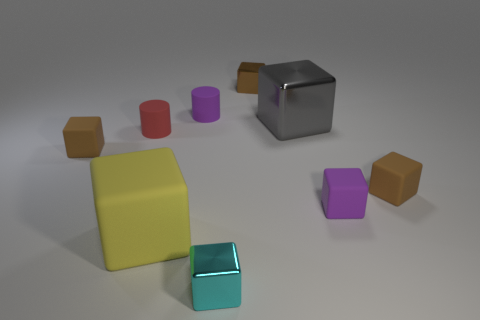Do the red thing and the brown metal thing have the same size?
Ensure brevity in your answer.  Yes. Are there any big yellow cubes that have the same material as the small purple cylinder?
Keep it short and to the point. Yes. What number of small blocks are both on the right side of the cyan thing and on the left side of the gray object?
Give a very brief answer. 1. What is the material of the large block that is behind the large matte thing?
Offer a very short reply. Metal. How many small rubber cylinders are the same color as the large rubber object?
Your answer should be compact. 0. The purple cylinder that is the same material as the red cylinder is what size?
Provide a short and direct response. Small. What number of things are small cylinders or large brown metal cylinders?
Give a very brief answer. 2. What color is the rubber cylinder that is to the right of the large yellow rubber cube?
Your answer should be compact. Purple. There is another thing that is the same shape as the small red rubber thing; what size is it?
Your answer should be compact. Small. What number of things are things behind the red object or small brown shiny blocks behind the small cyan metallic block?
Offer a very short reply. 3. 